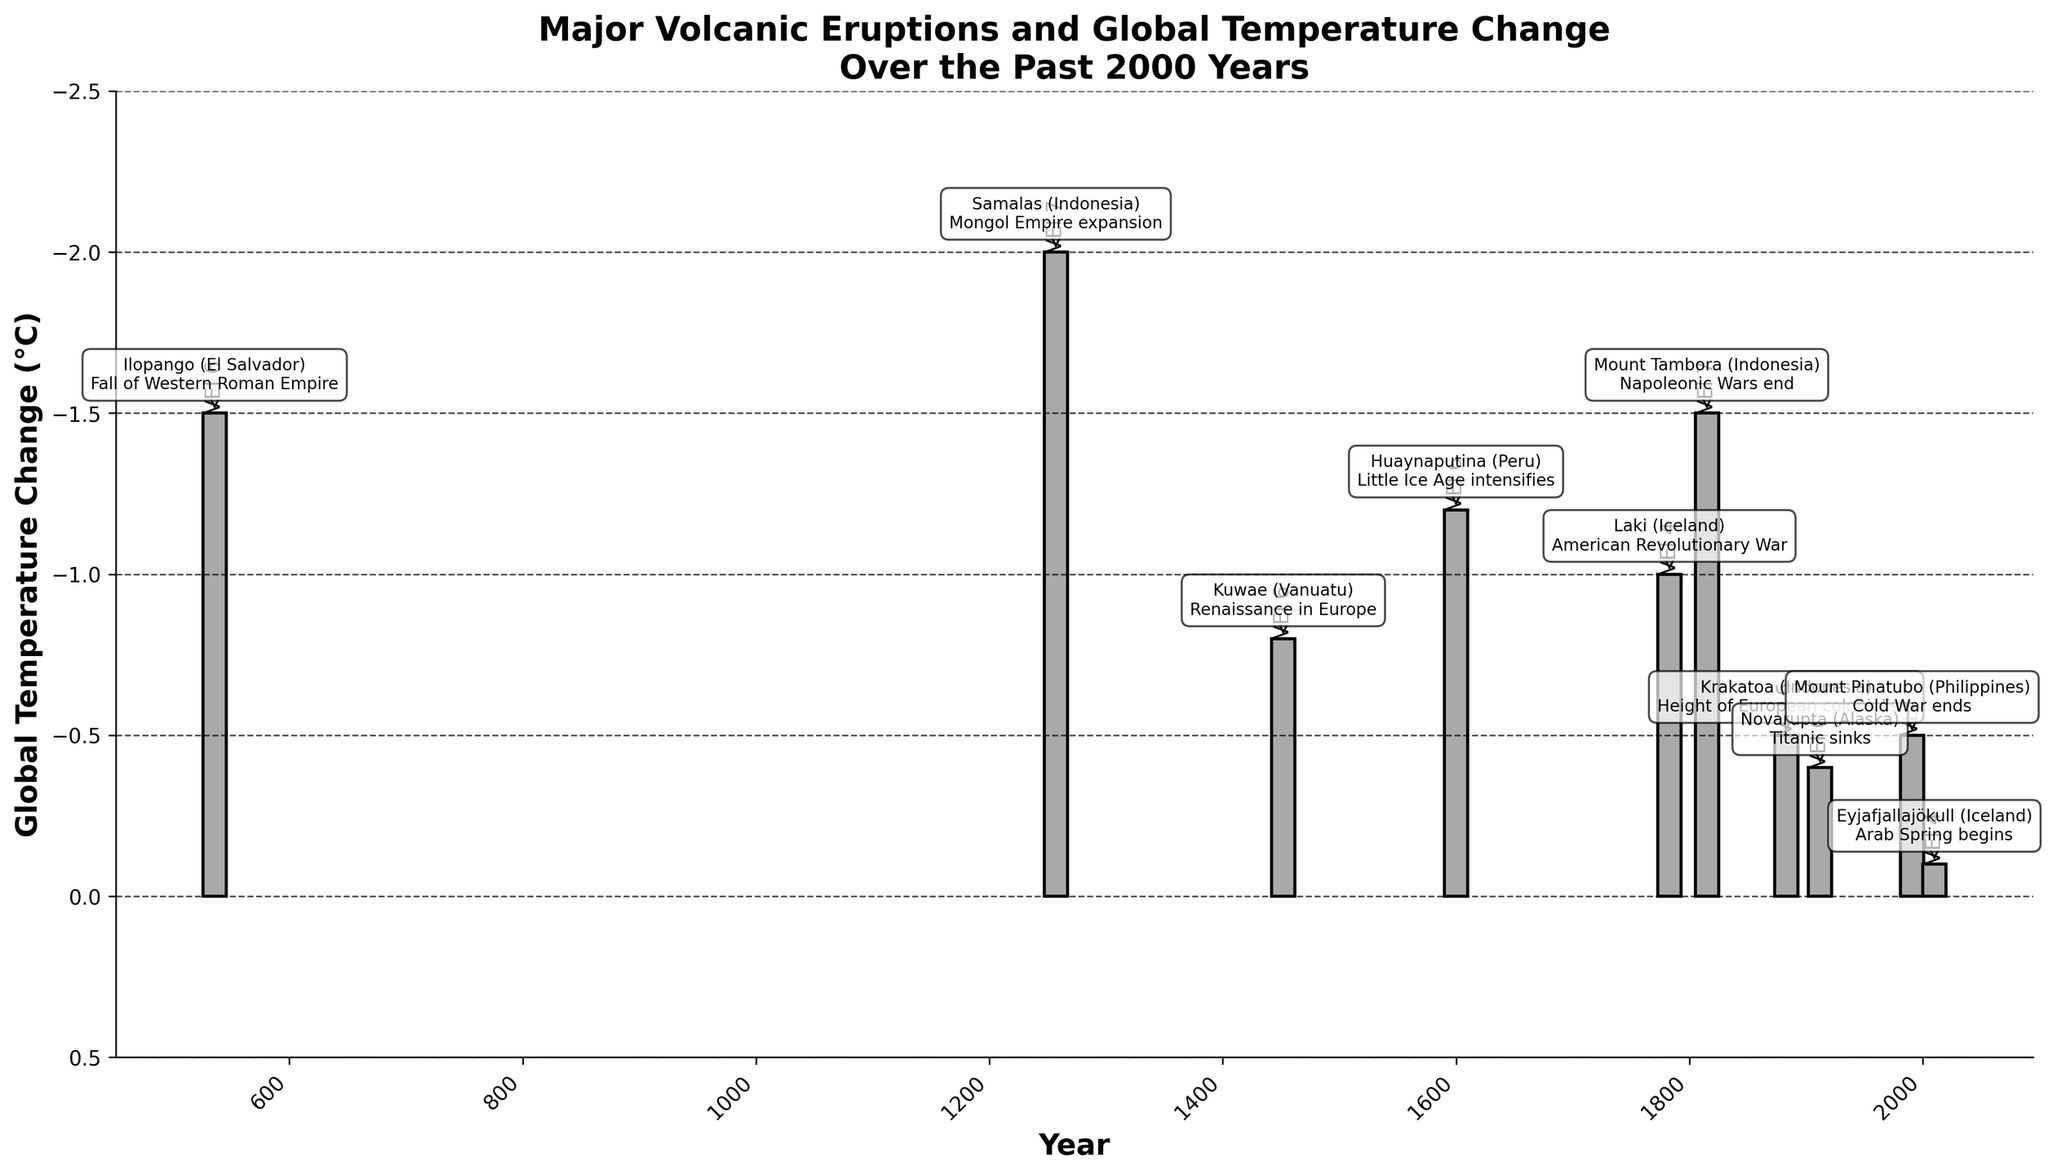What year did the volcanic eruption with the highest VEI occur? Find the bar with the label indicating the highest VEI. The bar labeled "VEI 7" corresponds to the years 1257 and 1815.
Answer: 1257 and 1815 Which volcanic eruption caused the most significant drop in global temperature? Look for the bar with the greatest decrease in height. The eruption in 1257 (Samalas, Indonesia) shows the most significant drop of -2.0°C.
Answer: 1257 How does the global temperature change caused by the 536 eruption compare with that of the 1815 eruption? Check the height of the bars for the 536 and 1815 eruptions. The 536 eruption caused a drop of -1.5°C, and the 1815 eruption also caused a drop of -1.5°C.
Answer: Equal Which of the eruptions in the 20th century had the least impact on global temperature? Identify the eruptions in the 20th century (1912, 1991) and compare their bars. The eruption in 1991 (Mount Pinatubo) caused a -0.5°C drop, and the 1912 eruption (Novarupta) caused a -0.4°C drop. The 1912 eruption had the least impact.
Answer: 1912 What is the average global temperature change caused by the volcanic eruptions listed? Sum all the global temperature changes: (-1.5) + (-2.0) + (-0.8) + (-1.2) + (-1.0) + (-1.5) + (-0.5) + (-0.4) + (-0.5) + (-0.1) = -9.5. There are 10 data points, so divide by 10: -9.5/10 = -0.95°C.
Answer: -0.95°C How did the global temperature change due to the 1883 Krakatoa eruption compare to that due to the 2010 Eyjafjallajökull eruption? Compare the height of the bars for the 1883 and 2010 eruptions. The 1883 eruption caused a -0.5°C drop, while the 2010 eruption caused a -0.1°C drop.
Answer: The 1883 decrease was larger What historical event coincides with the volcanic eruption in 1452? Find the annotation next to the year 1452. The annotations indicate that this year marks the Renaissance in Europe.
Answer: Renaissance in Europe 